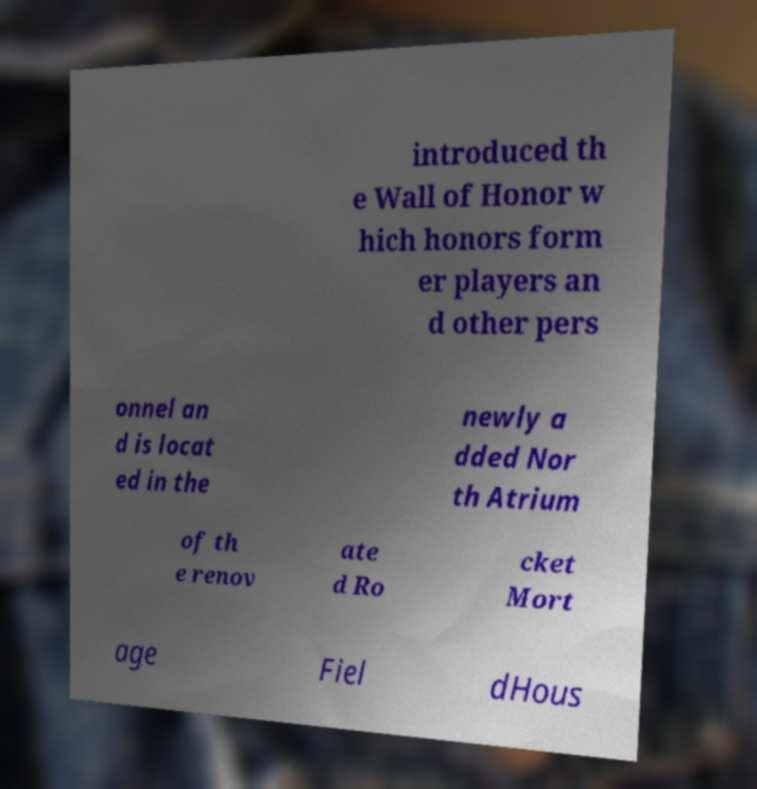Could you assist in decoding the text presented in this image and type it out clearly? introduced th e Wall of Honor w hich honors form er players an d other pers onnel an d is locat ed in the newly a dded Nor th Atrium of th e renov ate d Ro cket Mort age Fiel dHous 